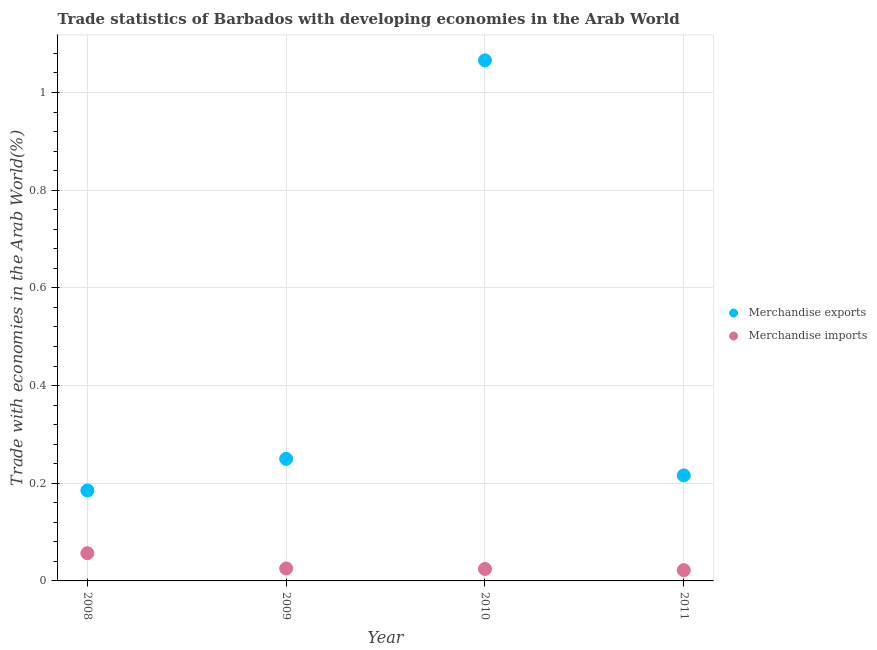How many different coloured dotlines are there?
Keep it short and to the point. 2. What is the merchandise exports in 2011?
Give a very brief answer. 0.22. Across all years, what is the maximum merchandise exports?
Your answer should be compact. 1.07. Across all years, what is the minimum merchandise exports?
Provide a short and direct response. 0.19. In which year was the merchandise imports minimum?
Keep it short and to the point. 2011. What is the total merchandise imports in the graph?
Your response must be concise. 0.13. What is the difference between the merchandise exports in 2009 and that in 2010?
Ensure brevity in your answer.  -0.82. What is the difference between the merchandise exports in 2011 and the merchandise imports in 2008?
Give a very brief answer. 0.16. What is the average merchandise exports per year?
Offer a terse response. 0.43. In the year 2009, what is the difference between the merchandise imports and merchandise exports?
Your answer should be compact. -0.22. What is the ratio of the merchandise imports in 2008 to that in 2011?
Your answer should be very brief. 2.58. Is the merchandise imports in 2009 less than that in 2011?
Provide a short and direct response. No. Is the difference between the merchandise exports in 2008 and 2010 greater than the difference between the merchandise imports in 2008 and 2010?
Offer a terse response. No. What is the difference between the highest and the second highest merchandise exports?
Your answer should be compact. 0.82. What is the difference between the highest and the lowest merchandise imports?
Offer a very short reply. 0.03. In how many years, is the merchandise imports greater than the average merchandise imports taken over all years?
Your response must be concise. 1. How many years are there in the graph?
Your response must be concise. 4. Are the values on the major ticks of Y-axis written in scientific E-notation?
Give a very brief answer. No. Does the graph contain any zero values?
Your answer should be compact. No. How are the legend labels stacked?
Keep it short and to the point. Vertical. What is the title of the graph?
Keep it short and to the point. Trade statistics of Barbados with developing economies in the Arab World. What is the label or title of the Y-axis?
Make the answer very short. Trade with economies in the Arab World(%). What is the Trade with economies in the Arab World(%) in Merchandise exports in 2008?
Keep it short and to the point. 0.19. What is the Trade with economies in the Arab World(%) in Merchandise imports in 2008?
Keep it short and to the point. 0.06. What is the Trade with economies in the Arab World(%) of Merchandise exports in 2009?
Ensure brevity in your answer.  0.25. What is the Trade with economies in the Arab World(%) in Merchandise imports in 2009?
Offer a terse response. 0.03. What is the Trade with economies in the Arab World(%) in Merchandise exports in 2010?
Make the answer very short. 1.07. What is the Trade with economies in the Arab World(%) in Merchandise imports in 2010?
Give a very brief answer. 0.02. What is the Trade with economies in the Arab World(%) in Merchandise exports in 2011?
Offer a very short reply. 0.22. What is the Trade with economies in the Arab World(%) of Merchandise imports in 2011?
Offer a very short reply. 0.02. Across all years, what is the maximum Trade with economies in the Arab World(%) of Merchandise exports?
Provide a short and direct response. 1.07. Across all years, what is the maximum Trade with economies in the Arab World(%) of Merchandise imports?
Keep it short and to the point. 0.06. Across all years, what is the minimum Trade with economies in the Arab World(%) of Merchandise exports?
Your answer should be very brief. 0.19. Across all years, what is the minimum Trade with economies in the Arab World(%) in Merchandise imports?
Offer a very short reply. 0.02. What is the total Trade with economies in the Arab World(%) in Merchandise exports in the graph?
Ensure brevity in your answer.  1.72. What is the total Trade with economies in the Arab World(%) in Merchandise imports in the graph?
Your answer should be compact. 0.13. What is the difference between the Trade with economies in the Arab World(%) of Merchandise exports in 2008 and that in 2009?
Provide a short and direct response. -0.06. What is the difference between the Trade with economies in the Arab World(%) in Merchandise imports in 2008 and that in 2009?
Offer a very short reply. 0.03. What is the difference between the Trade with economies in the Arab World(%) in Merchandise exports in 2008 and that in 2010?
Keep it short and to the point. -0.88. What is the difference between the Trade with economies in the Arab World(%) in Merchandise imports in 2008 and that in 2010?
Ensure brevity in your answer.  0.03. What is the difference between the Trade with economies in the Arab World(%) in Merchandise exports in 2008 and that in 2011?
Your answer should be compact. -0.03. What is the difference between the Trade with economies in the Arab World(%) of Merchandise imports in 2008 and that in 2011?
Make the answer very short. 0.03. What is the difference between the Trade with economies in the Arab World(%) of Merchandise exports in 2009 and that in 2010?
Your response must be concise. -0.82. What is the difference between the Trade with economies in the Arab World(%) in Merchandise imports in 2009 and that in 2010?
Give a very brief answer. 0. What is the difference between the Trade with economies in the Arab World(%) in Merchandise exports in 2009 and that in 2011?
Give a very brief answer. 0.03. What is the difference between the Trade with economies in the Arab World(%) of Merchandise imports in 2009 and that in 2011?
Offer a terse response. 0. What is the difference between the Trade with economies in the Arab World(%) in Merchandise exports in 2010 and that in 2011?
Ensure brevity in your answer.  0.85. What is the difference between the Trade with economies in the Arab World(%) of Merchandise imports in 2010 and that in 2011?
Your answer should be very brief. 0. What is the difference between the Trade with economies in the Arab World(%) of Merchandise exports in 2008 and the Trade with economies in the Arab World(%) of Merchandise imports in 2009?
Offer a very short reply. 0.16. What is the difference between the Trade with economies in the Arab World(%) of Merchandise exports in 2008 and the Trade with economies in the Arab World(%) of Merchandise imports in 2010?
Keep it short and to the point. 0.16. What is the difference between the Trade with economies in the Arab World(%) in Merchandise exports in 2008 and the Trade with economies in the Arab World(%) in Merchandise imports in 2011?
Provide a succinct answer. 0.16. What is the difference between the Trade with economies in the Arab World(%) in Merchandise exports in 2009 and the Trade with economies in the Arab World(%) in Merchandise imports in 2010?
Your response must be concise. 0.23. What is the difference between the Trade with economies in the Arab World(%) in Merchandise exports in 2009 and the Trade with economies in the Arab World(%) in Merchandise imports in 2011?
Make the answer very short. 0.23. What is the difference between the Trade with economies in the Arab World(%) of Merchandise exports in 2010 and the Trade with economies in the Arab World(%) of Merchandise imports in 2011?
Offer a terse response. 1.04. What is the average Trade with economies in the Arab World(%) of Merchandise exports per year?
Provide a short and direct response. 0.43. What is the average Trade with economies in the Arab World(%) in Merchandise imports per year?
Offer a terse response. 0.03. In the year 2008, what is the difference between the Trade with economies in the Arab World(%) in Merchandise exports and Trade with economies in the Arab World(%) in Merchandise imports?
Offer a terse response. 0.13. In the year 2009, what is the difference between the Trade with economies in the Arab World(%) of Merchandise exports and Trade with economies in the Arab World(%) of Merchandise imports?
Ensure brevity in your answer.  0.22. In the year 2010, what is the difference between the Trade with economies in the Arab World(%) of Merchandise exports and Trade with economies in the Arab World(%) of Merchandise imports?
Offer a very short reply. 1.04. In the year 2011, what is the difference between the Trade with economies in the Arab World(%) of Merchandise exports and Trade with economies in the Arab World(%) of Merchandise imports?
Provide a succinct answer. 0.19. What is the ratio of the Trade with economies in the Arab World(%) in Merchandise exports in 2008 to that in 2009?
Your response must be concise. 0.74. What is the ratio of the Trade with economies in the Arab World(%) of Merchandise imports in 2008 to that in 2009?
Your response must be concise. 2.22. What is the ratio of the Trade with economies in the Arab World(%) of Merchandise exports in 2008 to that in 2010?
Your response must be concise. 0.17. What is the ratio of the Trade with economies in the Arab World(%) of Merchandise imports in 2008 to that in 2010?
Your answer should be compact. 2.32. What is the ratio of the Trade with economies in the Arab World(%) in Merchandise exports in 2008 to that in 2011?
Offer a terse response. 0.86. What is the ratio of the Trade with economies in the Arab World(%) of Merchandise imports in 2008 to that in 2011?
Your answer should be compact. 2.58. What is the ratio of the Trade with economies in the Arab World(%) of Merchandise exports in 2009 to that in 2010?
Your answer should be compact. 0.23. What is the ratio of the Trade with economies in the Arab World(%) in Merchandise imports in 2009 to that in 2010?
Your answer should be very brief. 1.04. What is the ratio of the Trade with economies in the Arab World(%) of Merchandise exports in 2009 to that in 2011?
Offer a very short reply. 1.16. What is the ratio of the Trade with economies in the Arab World(%) of Merchandise imports in 2009 to that in 2011?
Give a very brief answer. 1.16. What is the ratio of the Trade with economies in the Arab World(%) in Merchandise exports in 2010 to that in 2011?
Your answer should be very brief. 4.93. What is the ratio of the Trade with economies in the Arab World(%) of Merchandise imports in 2010 to that in 2011?
Make the answer very short. 1.11. What is the difference between the highest and the second highest Trade with economies in the Arab World(%) in Merchandise exports?
Your answer should be compact. 0.82. What is the difference between the highest and the second highest Trade with economies in the Arab World(%) in Merchandise imports?
Keep it short and to the point. 0.03. What is the difference between the highest and the lowest Trade with economies in the Arab World(%) in Merchandise exports?
Offer a terse response. 0.88. What is the difference between the highest and the lowest Trade with economies in the Arab World(%) of Merchandise imports?
Offer a terse response. 0.03. 